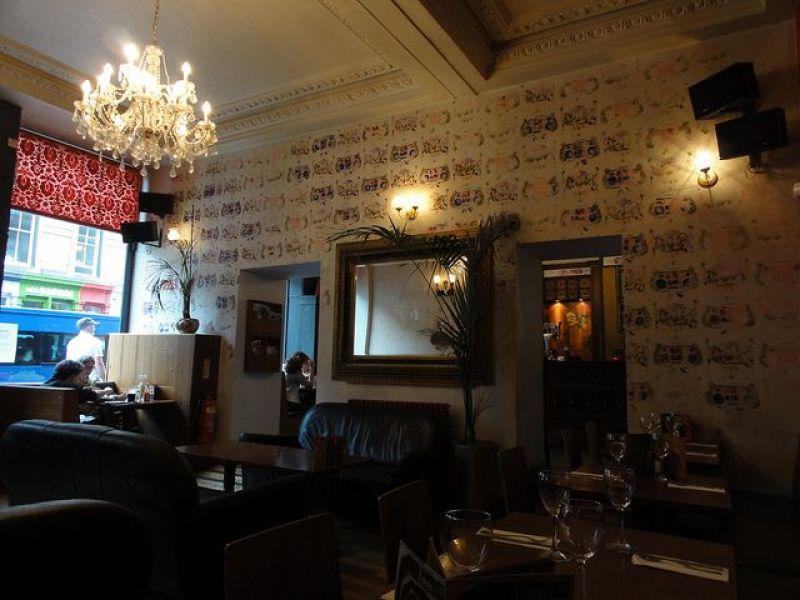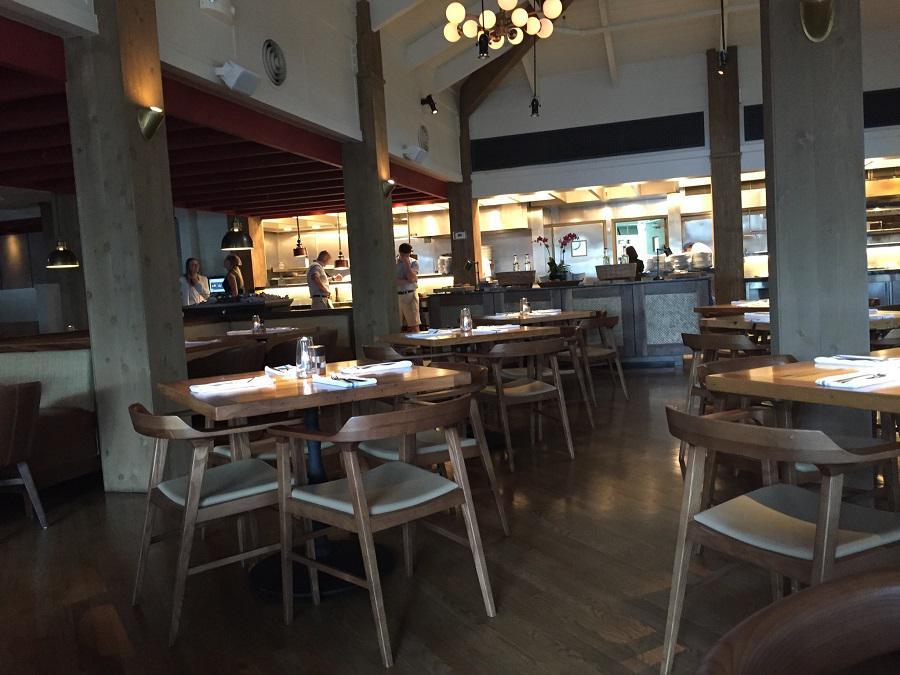The first image is the image on the left, the second image is the image on the right. Assess this claim about the two images: "In at least one image there is a single long bar with at least two black hanging lights over it.". Correct or not? Answer yes or no. No. 